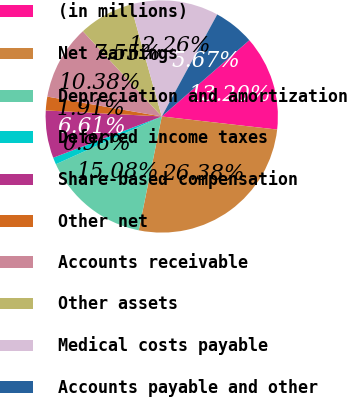<chart> <loc_0><loc_0><loc_500><loc_500><pie_chart><fcel>(in millions)<fcel>Net earnings<fcel>Depreciation and amortization<fcel>Deferred income taxes<fcel>Share-based compensation<fcel>Other net<fcel>Accounts receivable<fcel>Other assets<fcel>Medical costs payable<fcel>Accounts payable and other<nl><fcel>13.2%<fcel>26.38%<fcel>15.08%<fcel>0.96%<fcel>6.61%<fcel>1.91%<fcel>10.38%<fcel>7.55%<fcel>12.26%<fcel>5.67%<nl></chart> 